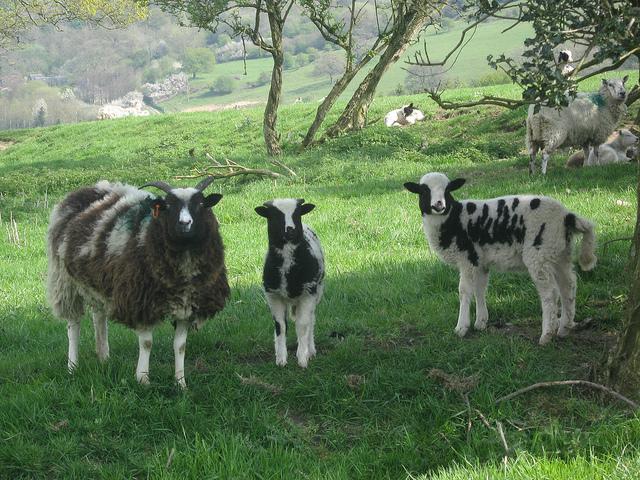The animals are all black?
Give a very brief answer. No. Which animal has the most unusual pattern?
Quick response, please. Goat. What type of animal is on the field?
Short answer required. Sheep. Are any animals lying down?
Give a very brief answer. Yes. How many dogs are in the photo?
Quick response, please. 0. 